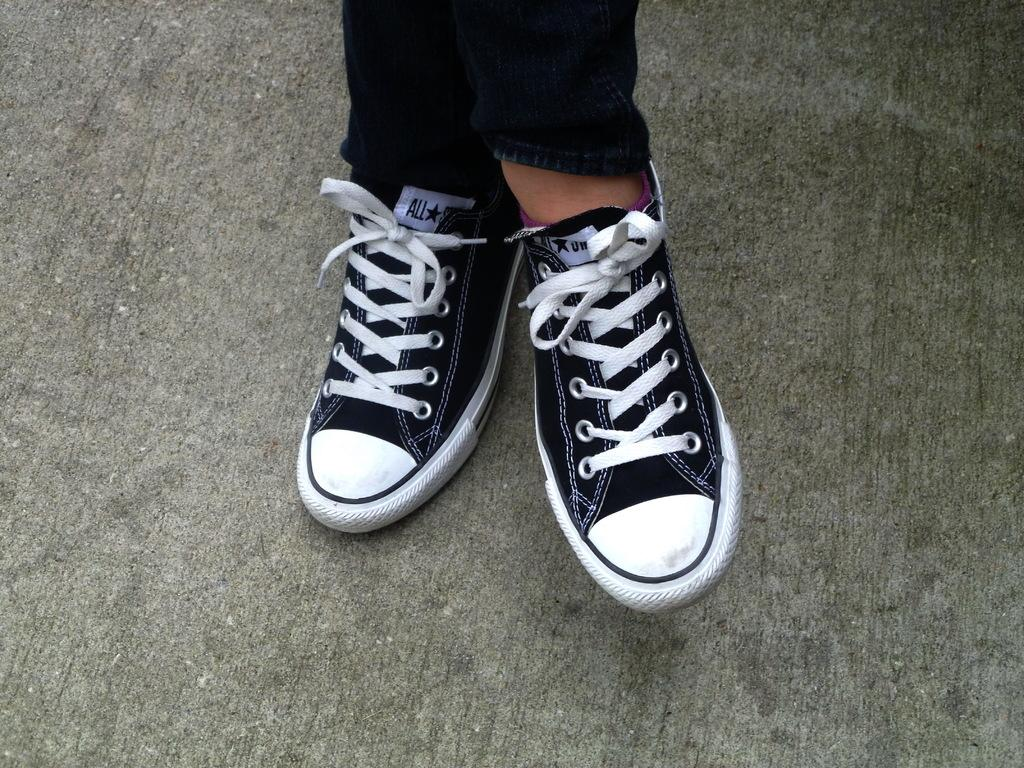What part of a person can be seen in the image? There are legs visible in the image. What type of footwear is the person wearing? The person is wearing shoes. What is the distribution of respect among the people in the image? There is no indication of people or any social interactions in the image, so it is not possible to determine the distribution of respect. 